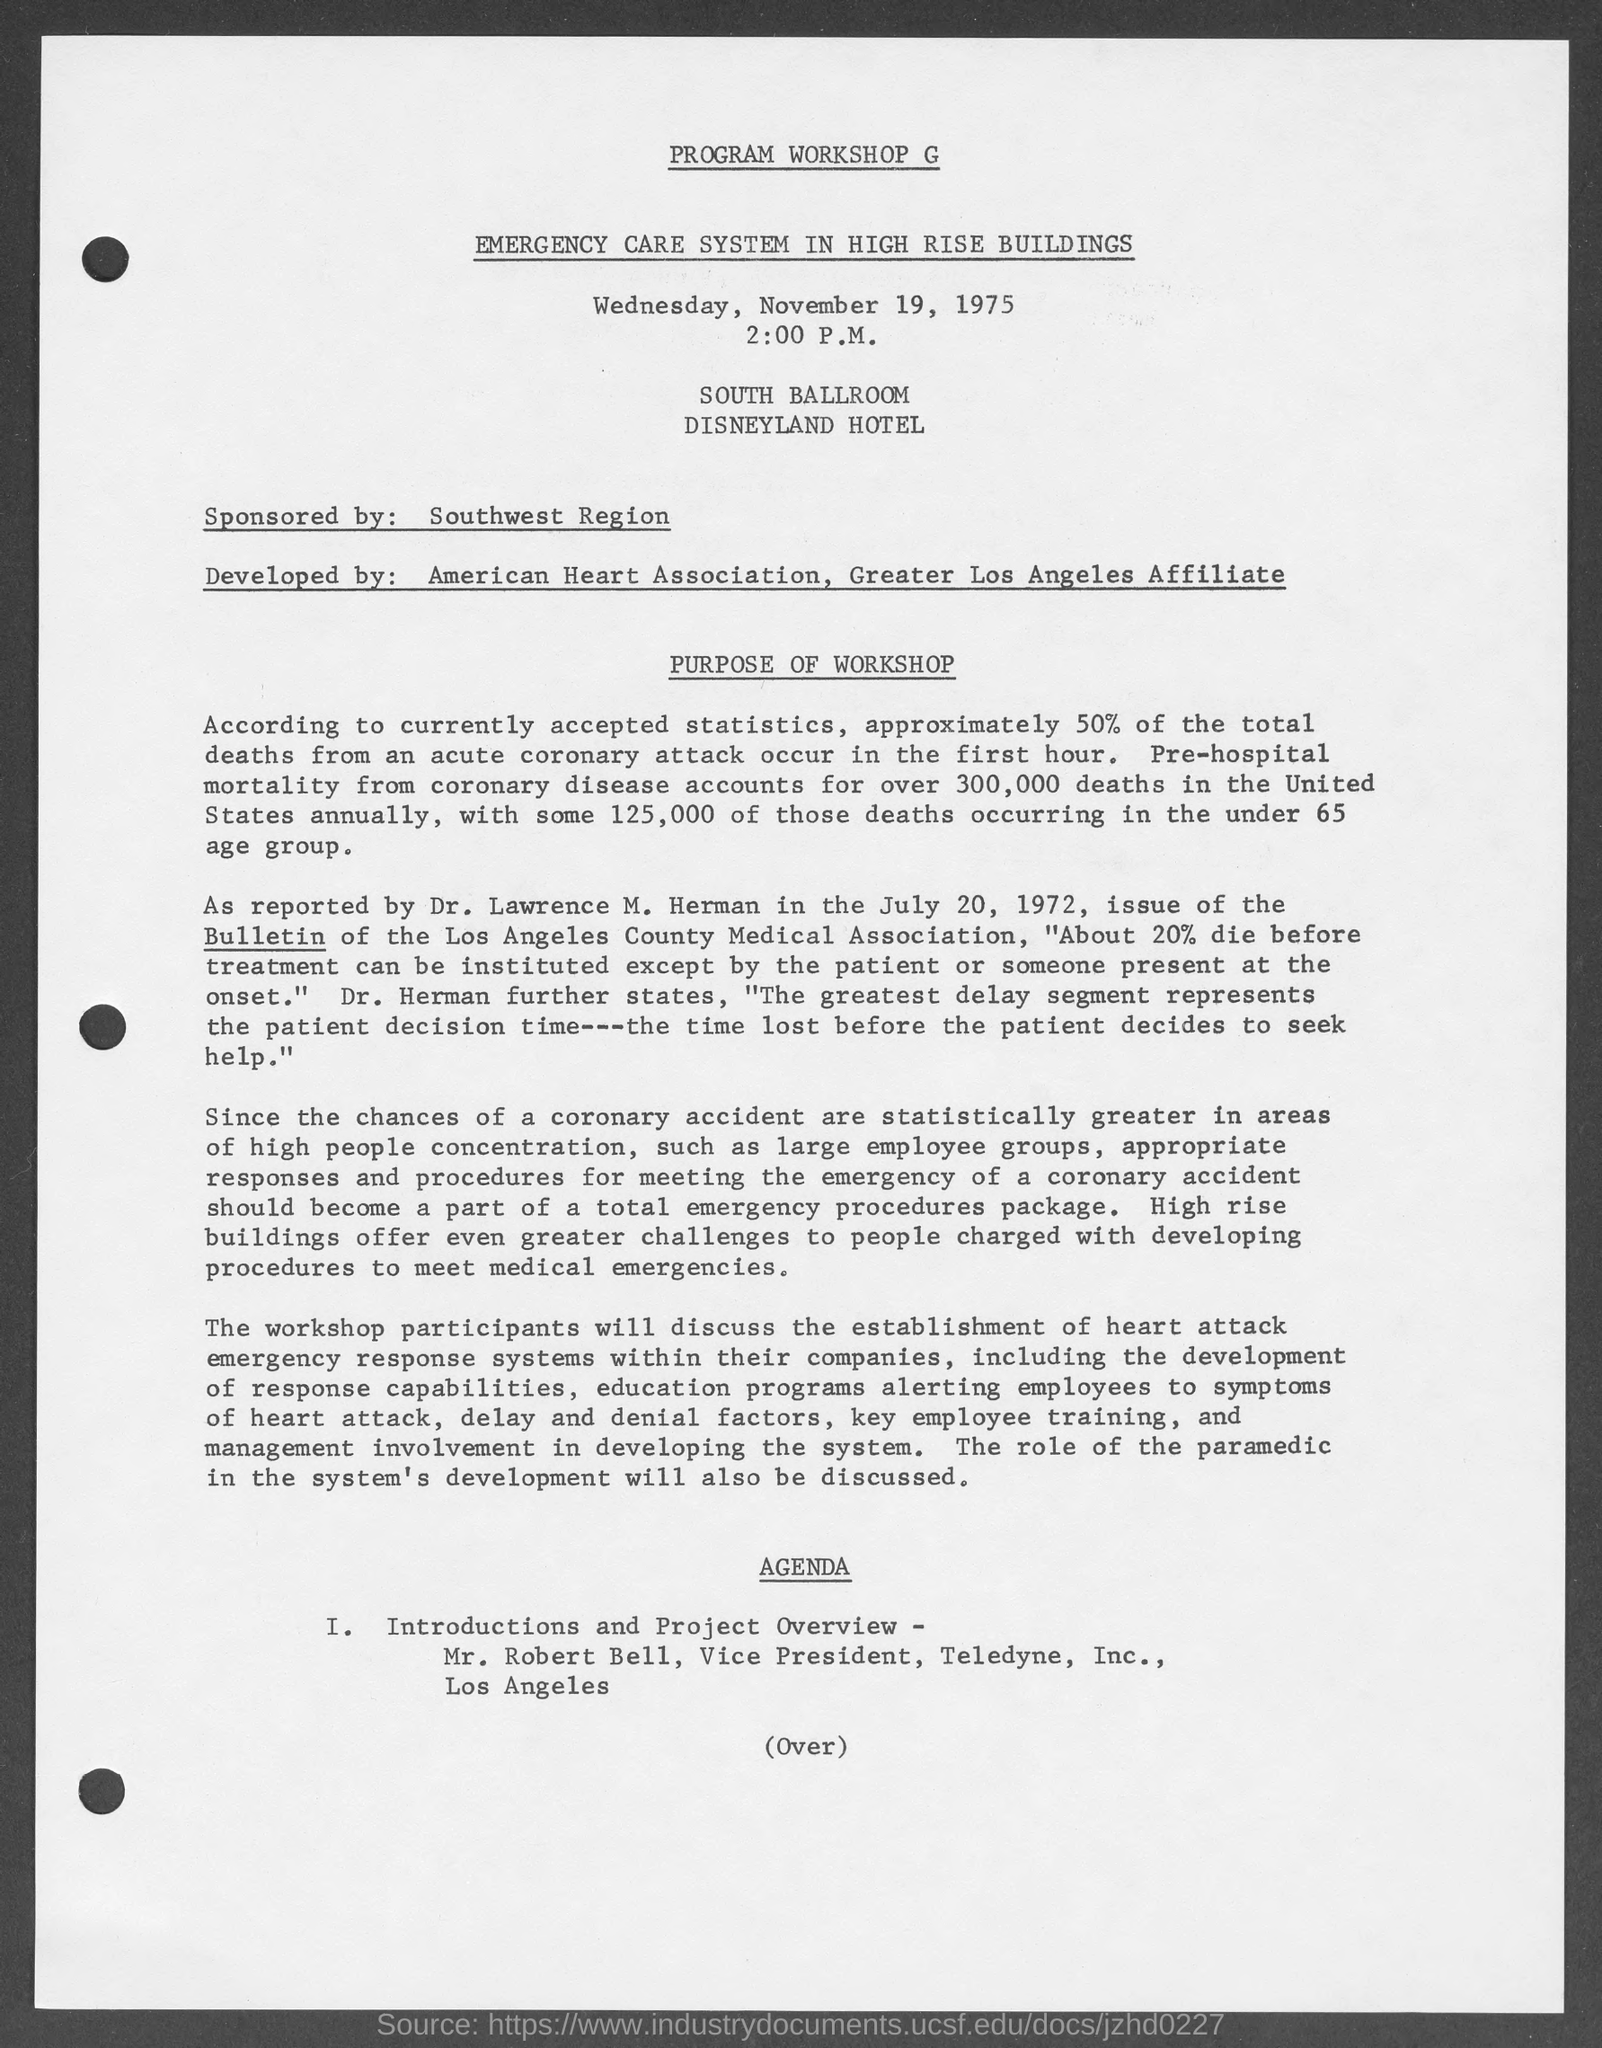What is the scheduled date of the given program ?
Ensure brevity in your answer.  Wednesday, November 19, 1975. What is the scheduled time of the given program ?
Provide a short and direct response. 2:00 p.m. What is the name of the hotel mentioned in the given program ?
Provide a short and direct response. Disneyland hotel. Who is the sponsor for the given program ?
Provide a succinct answer. Southwest Region. Who is the speaker for introductions and project overview mentioned in the given agenda ?
Provide a short and direct response. Mr. Robert Bell. What is the designation of mr. robert bell ?
Provide a succinct answer. Vice president. 